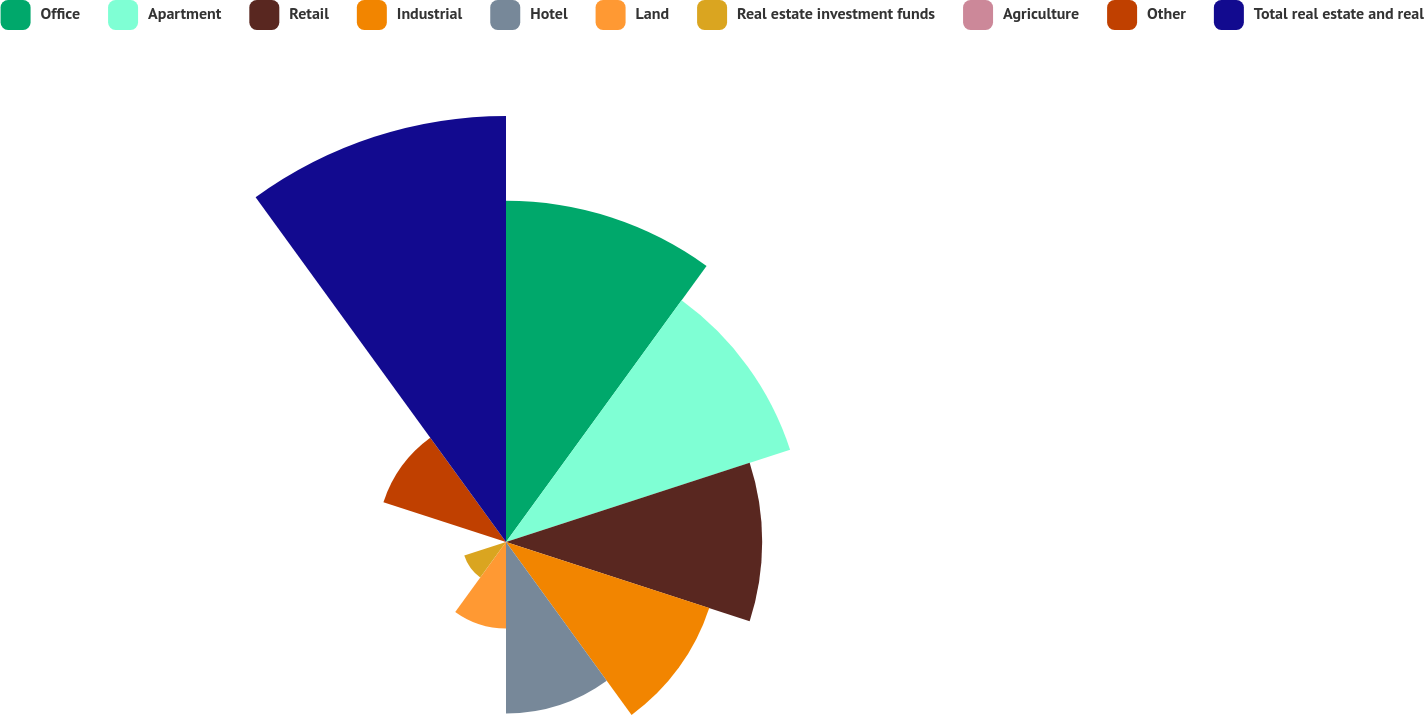Convert chart. <chart><loc_0><loc_0><loc_500><loc_500><pie_chart><fcel>Office<fcel>Apartment<fcel>Retail<fcel>Industrial<fcel>Hotel<fcel>Land<fcel>Real estate investment funds<fcel>Agriculture<fcel>Other<fcel>Total real estate and real<nl><fcel>17.34%<fcel>15.18%<fcel>13.02%<fcel>10.86%<fcel>8.71%<fcel>4.39%<fcel>2.23%<fcel>0.08%<fcel>6.55%<fcel>21.65%<nl></chart> 